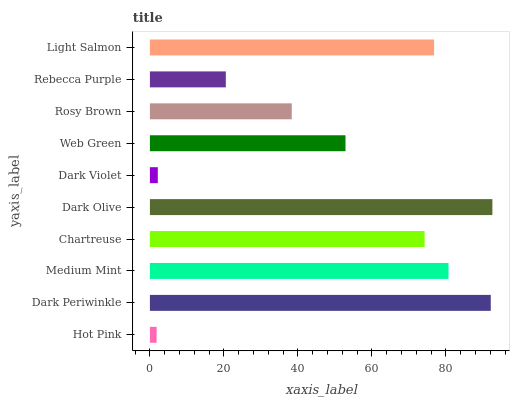Is Hot Pink the minimum?
Answer yes or no. Yes. Is Dark Olive the maximum?
Answer yes or no. Yes. Is Dark Periwinkle the minimum?
Answer yes or no. No. Is Dark Periwinkle the maximum?
Answer yes or no. No. Is Dark Periwinkle greater than Hot Pink?
Answer yes or no. Yes. Is Hot Pink less than Dark Periwinkle?
Answer yes or no. Yes. Is Hot Pink greater than Dark Periwinkle?
Answer yes or no. No. Is Dark Periwinkle less than Hot Pink?
Answer yes or no. No. Is Chartreuse the high median?
Answer yes or no. Yes. Is Web Green the low median?
Answer yes or no. Yes. Is Dark Periwinkle the high median?
Answer yes or no. No. Is Dark Violet the low median?
Answer yes or no. No. 